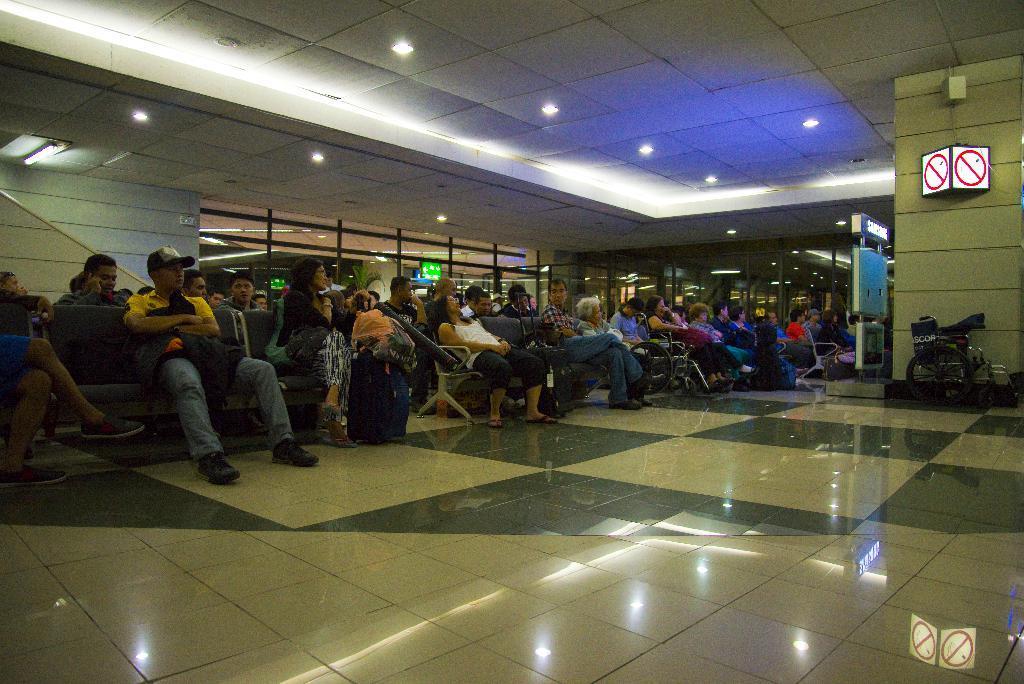Can you describe this image briefly? In this image we can see few people sitting on the chairs in a room, there is a sign board to the wall, there are lights to the ceiling and a wheel chair near the wall. 